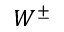Convert formula to latex. <formula><loc_0><loc_0><loc_500><loc_500>W ^ { \pm }</formula> 